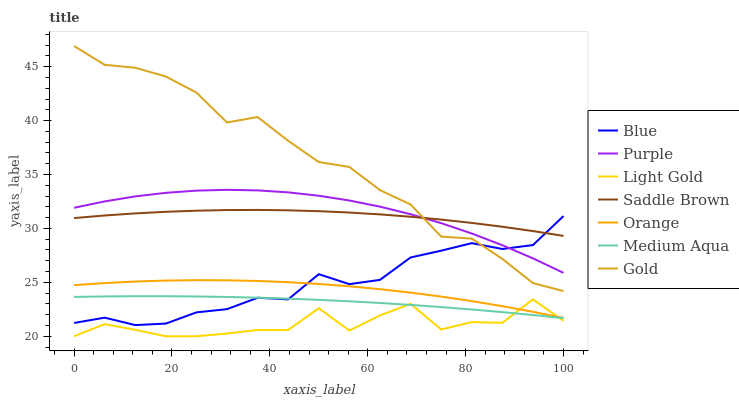Does Light Gold have the minimum area under the curve?
Answer yes or no. Yes. Does Gold have the maximum area under the curve?
Answer yes or no. Yes. Does Purple have the minimum area under the curve?
Answer yes or no. No. Does Purple have the maximum area under the curve?
Answer yes or no. No. Is Medium Aqua the smoothest?
Answer yes or no. Yes. Is Light Gold the roughest?
Answer yes or no. Yes. Is Gold the smoothest?
Answer yes or no. No. Is Gold the roughest?
Answer yes or no. No. Does Light Gold have the lowest value?
Answer yes or no. Yes. Does Gold have the lowest value?
Answer yes or no. No. Does Gold have the highest value?
Answer yes or no. Yes. Does Purple have the highest value?
Answer yes or no. No. Is Light Gold less than Saddle Brown?
Answer yes or no. Yes. Is Gold greater than Orange?
Answer yes or no. Yes. Does Purple intersect Blue?
Answer yes or no. Yes. Is Purple less than Blue?
Answer yes or no. No. Is Purple greater than Blue?
Answer yes or no. No. Does Light Gold intersect Saddle Brown?
Answer yes or no. No. 